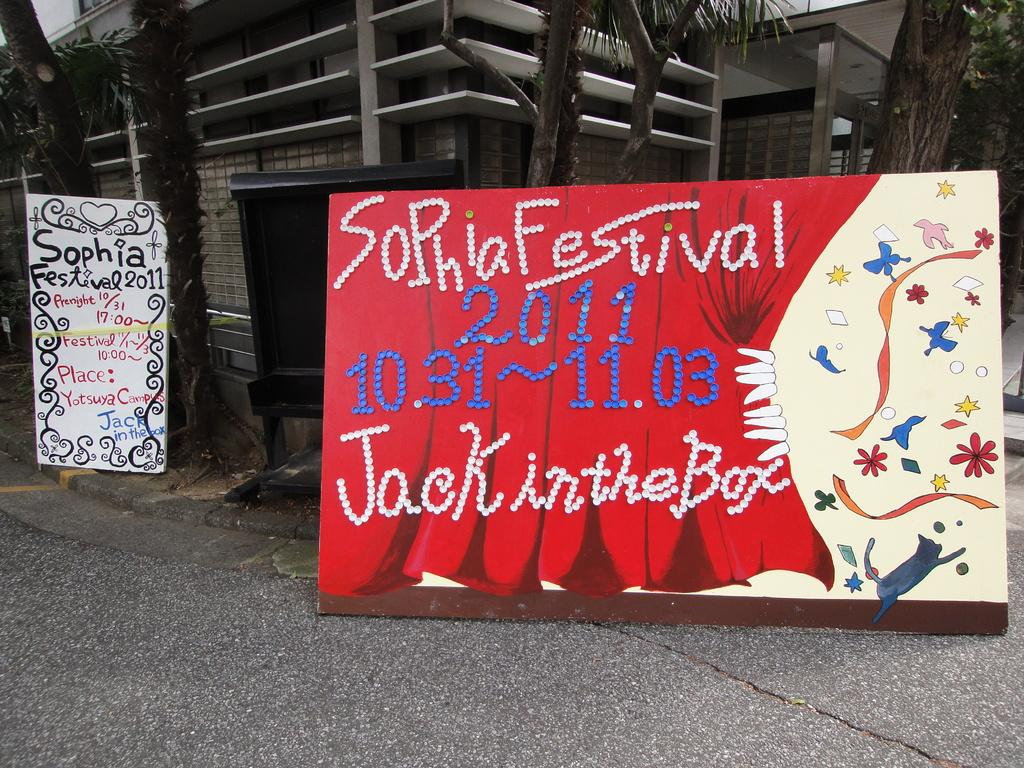What type of structure is present in the image? There is a building in the image. What can be seen on the boards in the image? The boards have text and images in the image. What type of vegetation is visible in the image? There are trees visible in the image. What material is the metal object made of in the image? The metal object in the image is made of metal. What is visible beneath the building and trees in the image? The ground is visible in the image. What type of pest can be seen crawling on the building in the image? There is no pest visible on the building in the image. What type of cloud formation can be seen in the sky in the image? There is no sky or cloud formation visible in the image. 